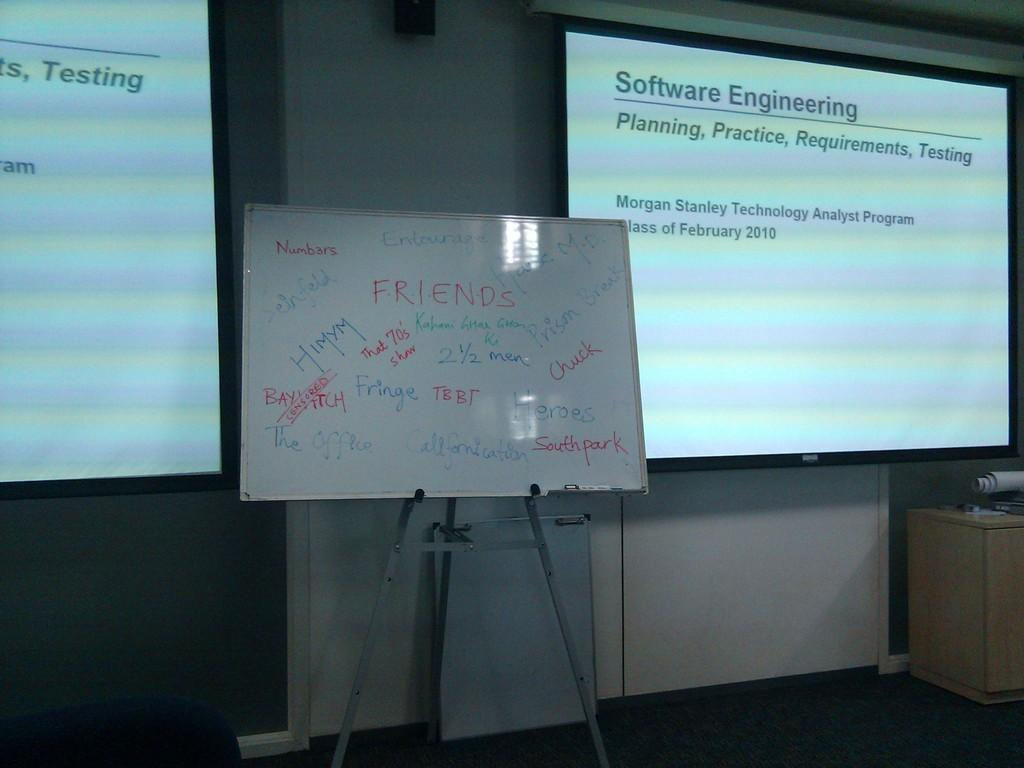<image>
Render a clear and concise summary of the photo. Screen which shows the words "Software Engineering" in black. 